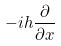<formula> <loc_0><loc_0><loc_500><loc_500>- i h \frac { \partial } { \partial x }</formula> 